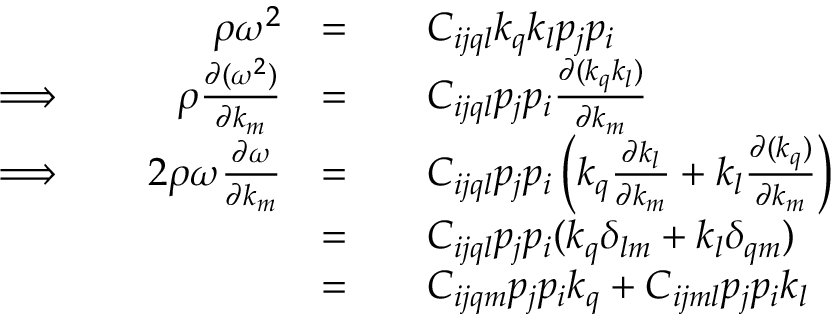<formula> <loc_0><loc_0><loc_500><loc_500>\begin{array} { r l r l r l } & { \rho \omega ^ { 2 } } & { = } & & { C _ { i j q l } k _ { q } k _ { l } p _ { j } p _ { i } } \\ { \Longrightarrow \, } & { \rho \frac { \partial ( \omega ^ { 2 } ) } { \partial k _ { m } } } & { = } & & { C _ { i j q l } p _ { j } p _ { i } \frac { \partial ( k _ { q } k _ { l } ) } { \partial k _ { m } } } \\ { \Longrightarrow \, } & { 2 \rho \omega \frac { \partial \omega } { \partial k _ { m } } } & { = } & & { C _ { i j q l } p _ { j } p _ { i } \left ( k _ { q } \frac { \partial k _ { l } } { \partial k _ { m } } + k _ { l } \frac { \partial ( k _ { q } ) } { \partial k _ { m } } \right ) } \\ & & { = } & & { C _ { i j q l } p _ { j } p _ { i } ( k _ { q } \delta _ { l m } + k _ { l } \delta _ { q m } ) } \\ & & { = } & & { C _ { i j q m } p _ { j } p _ { i } k _ { q } + C _ { i j m l } p _ { j } p _ { i } k _ { l } } \end{array}</formula> 